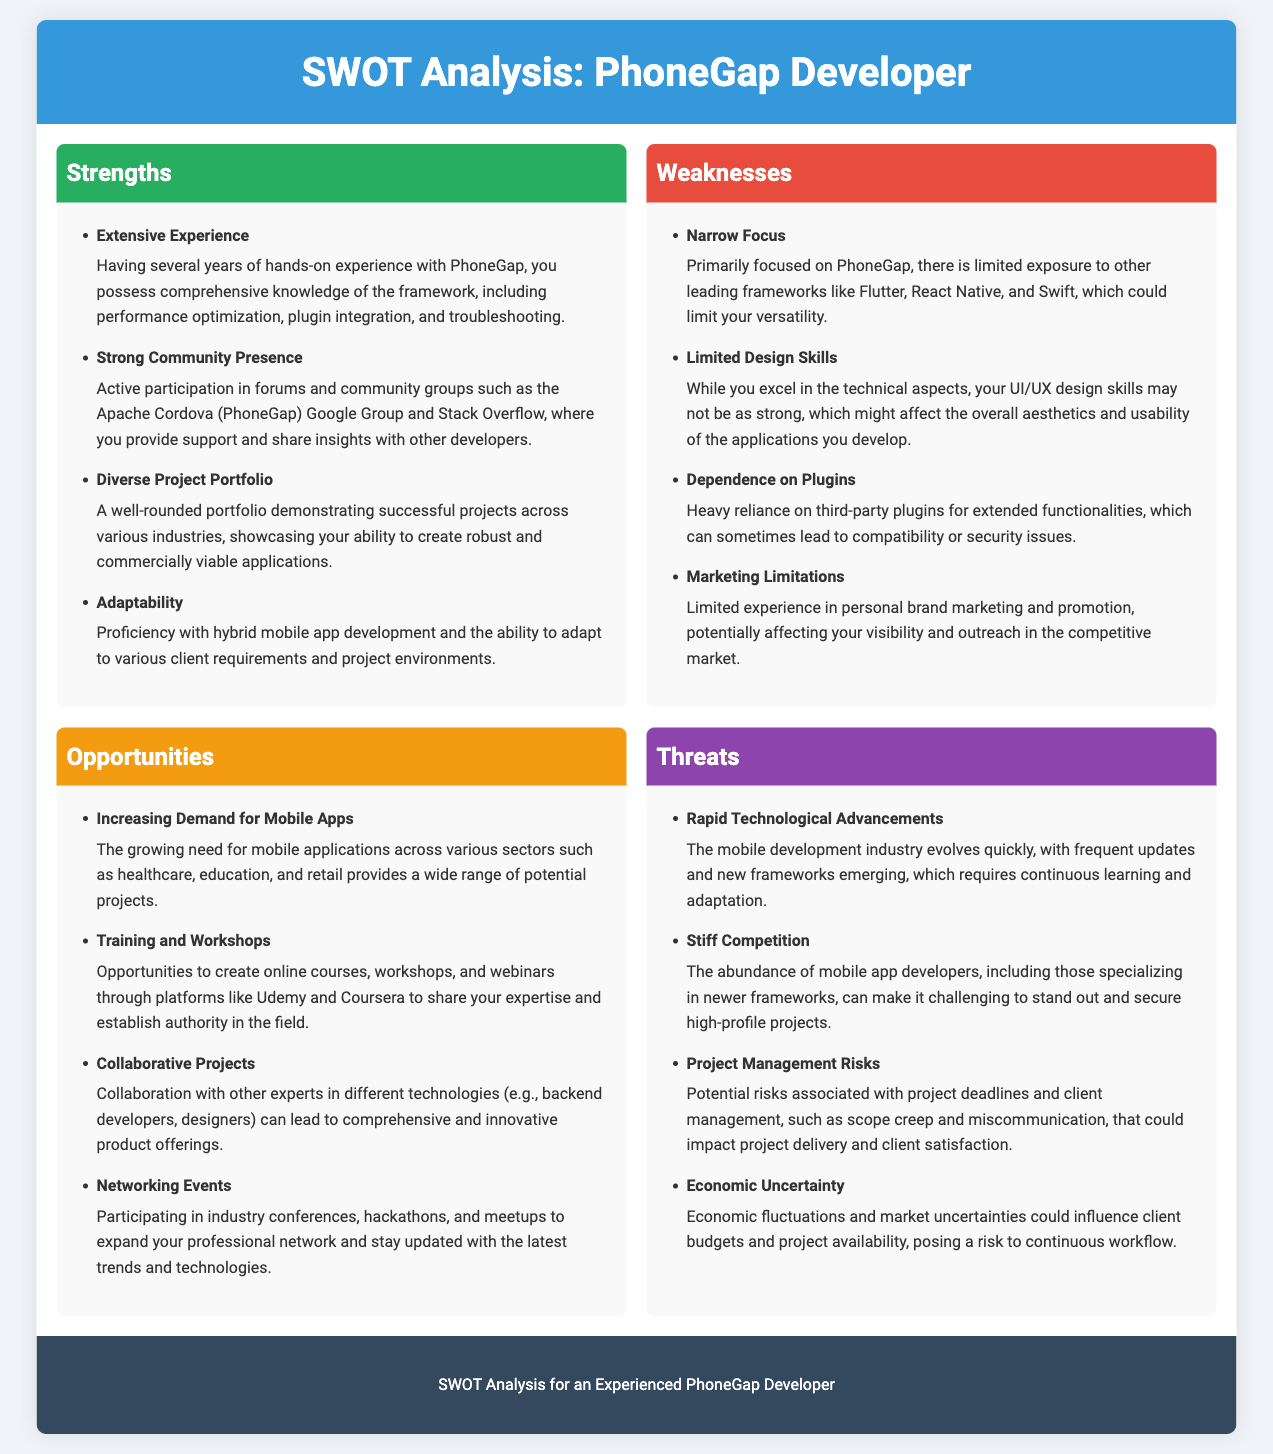what are the strengths listed in the analysis? The analysis lists four strengths: Extensive Experience, Strong Community Presence, Diverse Project Portfolio, Adaptability.
Answer: Extensive Experience, Strong Community Presence, Diverse Project Portfolio, Adaptability how many weaknesses are identified in the document? The document identifies four weaknesses that are outlined in the SWOT analysis section.
Answer: 4 what is one opportunity mentioned for PhoneGap developers? The document mentions several opportunities, one of which is increasing demand for mobile apps across various sectors.
Answer: Increasing Demand for Mobile Apps what is one of the threats due to competition? One threat mentioned is stiff competition among mobile app developers specializing in newer frameworks.
Answer: Stiff Competition what does the workshop opportunity suggest? The opportunity for training and workshops suggests creating online courses on platforms like Udemy and Coursera.
Answer: Creating online courses which section discusses the risks associated with project management? The threats section discusses project management risks such as scope creep and miscommunication.
Answer: Threats what is a weakness related to plugins? The weakness regarding plugins highlights a heavy reliance on third-party plugins for functionalities, leading to potential issues.
Answer: Dependence on Plugins what can be inferred about the focus of the developer’s skills? It can be inferred that the developer's skills currently have a narrow focus primarily on PhoneGap, limiting versatility.
Answer: Narrow Focus 